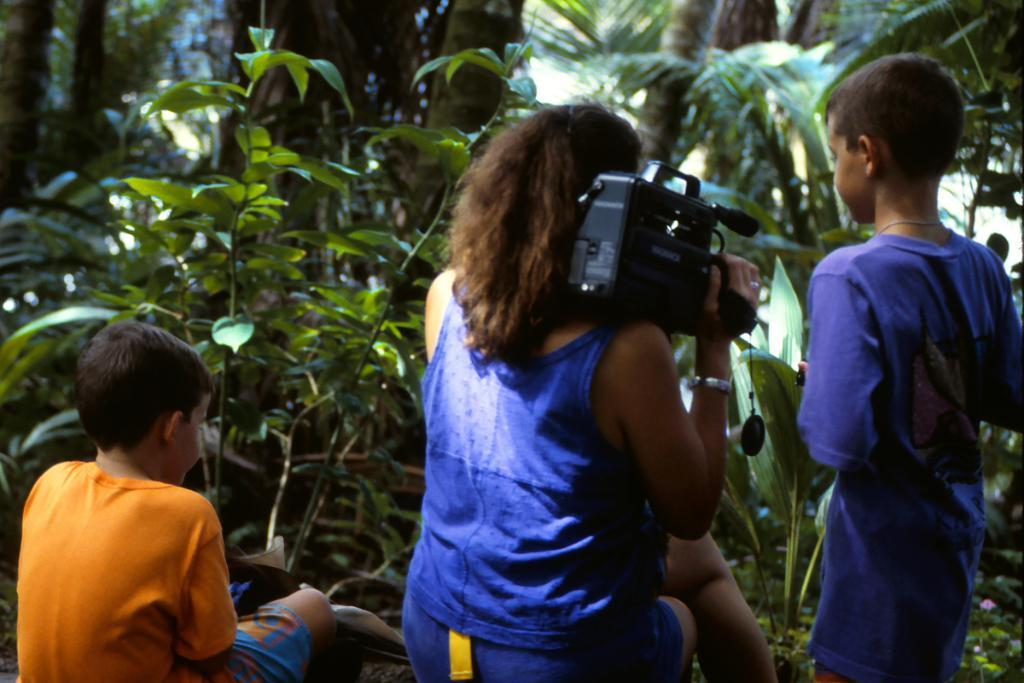How many people are in the image? There are three persons in the image. What is the woman holding in the image? The woman is holding a camera. What other objects or living organisms can be seen in the image? There are plants visible in the image. What type of effect does the deer have on the plants in the image? There is no deer present in the image, so it is not possible to determine any effect it might have on the plants. 